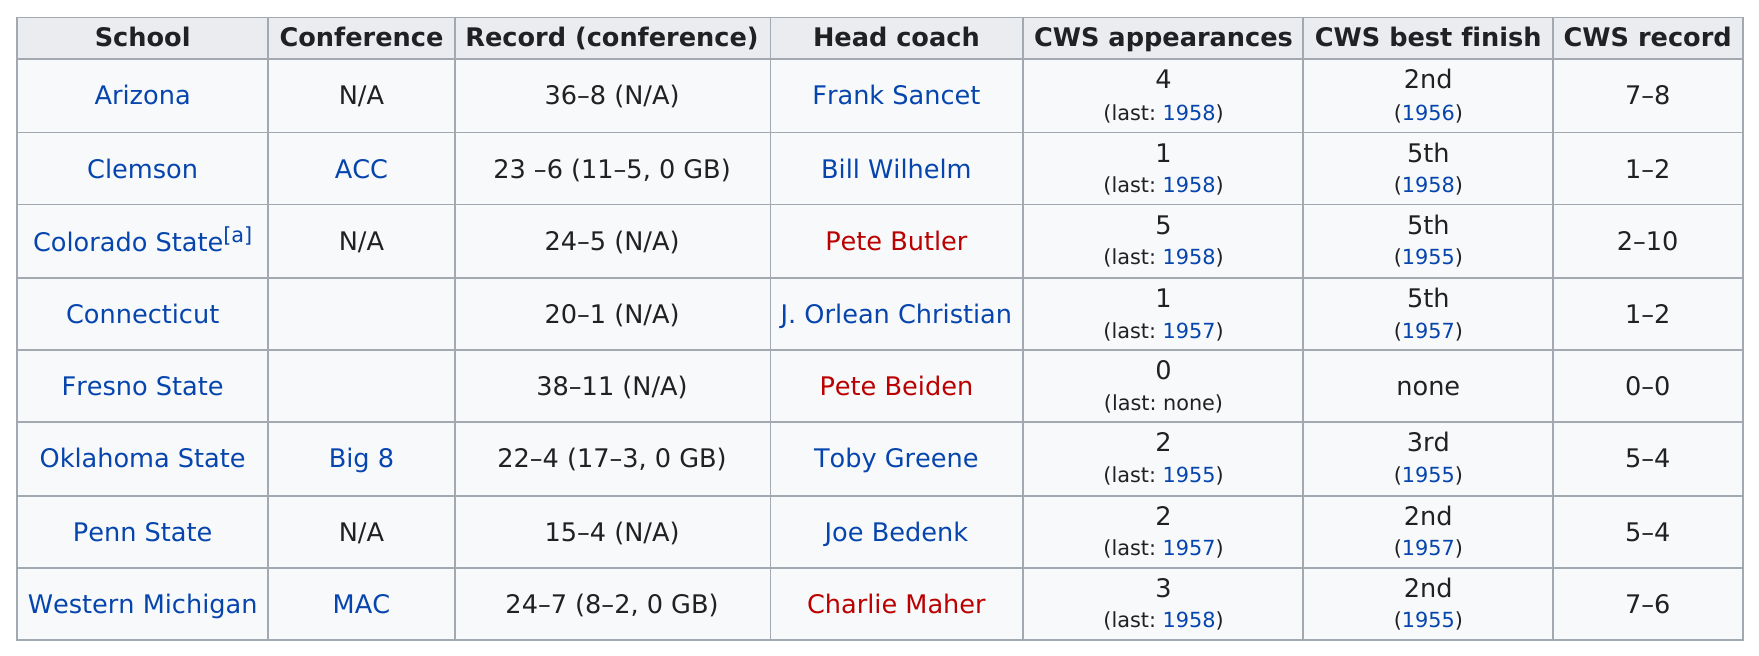Indicate a few pertinent items in this graphic. The question asks which team, Clemson or Western Michigan, has made more appearances in the College World Series. Western Michigan has the lead. Colorado State had the most appearances in the College World Series, making them the team to watch. The schools that came in last place in the College World Series with the best finish are Clemson, Colorado State, and Connecticut. Fresno State is the only school that has not appeared on CWS. In 1955, a total of three teams had their College World Series (CWS) best finish. 